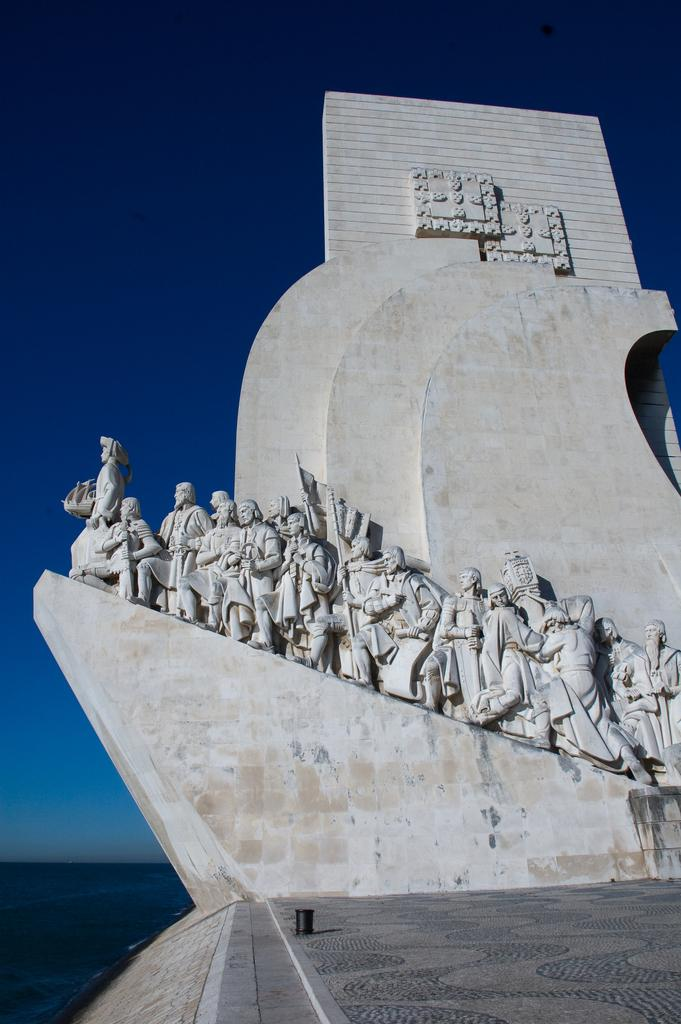What structure is located on the right side of the image? There is a monument on the right side of the image. What can be seen in the background of the image? There is water visible in the background of the image. What is visible at the top of the image? The sky is visible at the top of the image. How many geese are swimming in the soda in the image? There is no soda or geese present in the image. Is the monument emitting steam in the image? There is no steam visible in the image. 